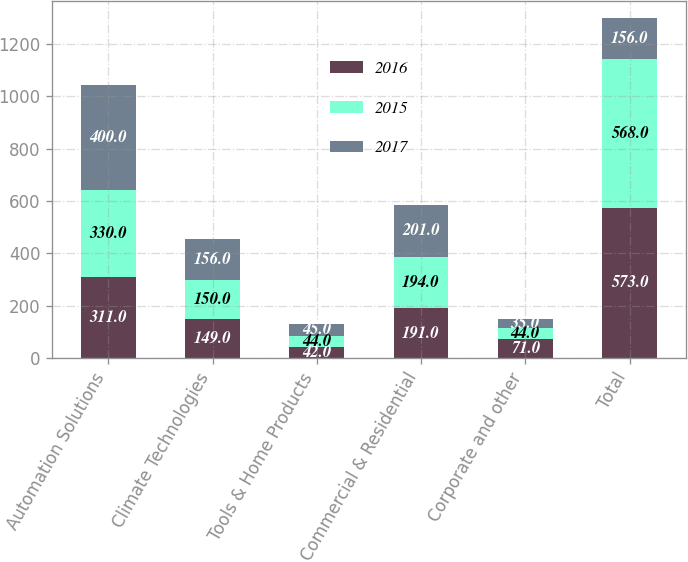Convert chart to OTSL. <chart><loc_0><loc_0><loc_500><loc_500><stacked_bar_chart><ecel><fcel>Automation Solutions<fcel>Climate Technologies<fcel>Tools & Home Products<fcel>Commercial & Residential<fcel>Corporate and other<fcel>Total<nl><fcel>2016<fcel>311<fcel>149<fcel>42<fcel>191<fcel>71<fcel>573<nl><fcel>2015<fcel>330<fcel>150<fcel>44<fcel>194<fcel>44<fcel>568<nl><fcel>2017<fcel>400<fcel>156<fcel>45<fcel>201<fcel>35<fcel>156<nl></chart> 